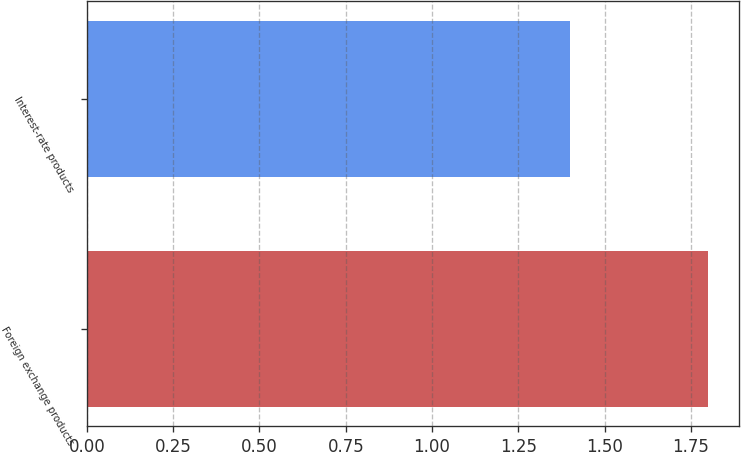<chart> <loc_0><loc_0><loc_500><loc_500><bar_chart><fcel>Foreign exchange products<fcel>Interest-rate products<nl><fcel>1.8<fcel>1.4<nl></chart> 